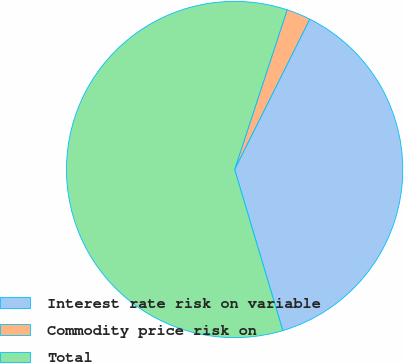<chart> <loc_0><loc_0><loc_500><loc_500><pie_chart><fcel>Interest rate risk on variable<fcel>Commodity price risk on<fcel>Total<nl><fcel>38.0%<fcel>2.32%<fcel>59.68%<nl></chart> 